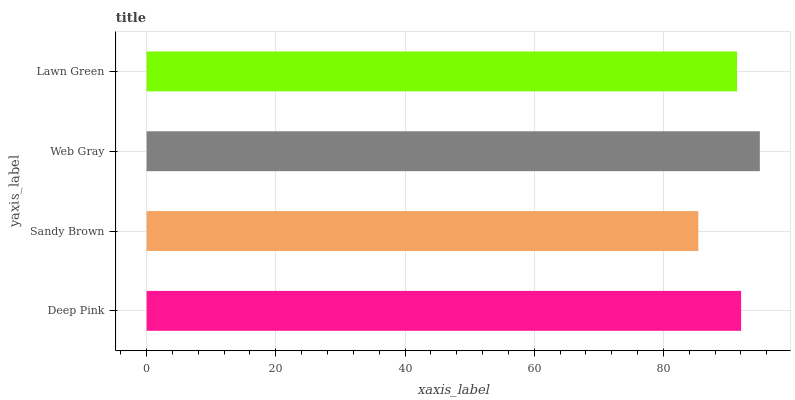Is Sandy Brown the minimum?
Answer yes or no. Yes. Is Web Gray the maximum?
Answer yes or no. Yes. Is Web Gray the minimum?
Answer yes or no. No. Is Sandy Brown the maximum?
Answer yes or no. No. Is Web Gray greater than Sandy Brown?
Answer yes or no. Yes. Is Sandy Brown less than Web Gray?
Answer yes or no. Yes. Is Sandy Brown greater than Web Gray?
Answer yes or no. No. Is Web Gray less than Sandy Brown?
Answer yes or no. No. Is Deep Pink the high median?
Answer yes or no. Yes. Is Lawn Green the low median?
Answer yes or no. Yes. Is Web Gray the high median?
Answer yes or no. No. Is Deep Pink the low median?
Answer yes or no. No. 